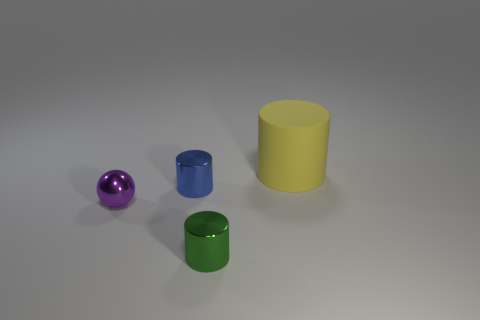Add 1 blue cylinders. How many objects exist? 5 Subtract all balls. How many objects are left? 3 Subtract 0 red balls. How many objects are left? 4 Subtract all small blue metallic objects. Subtract all tiny matte objects. How many objects are left? 3 Add 1 tiny blue cylinders. How many tiny blue cylinders are left? 2 Add 4 small cyan metallic cubes. How many small cyan metallic cubes exist? 4 